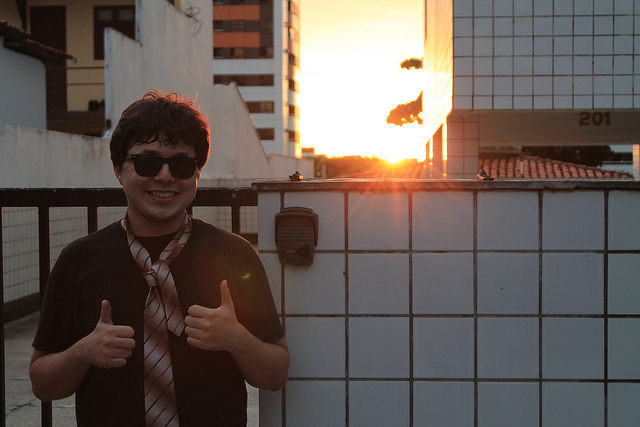Identify and read out the text in this image. 201 